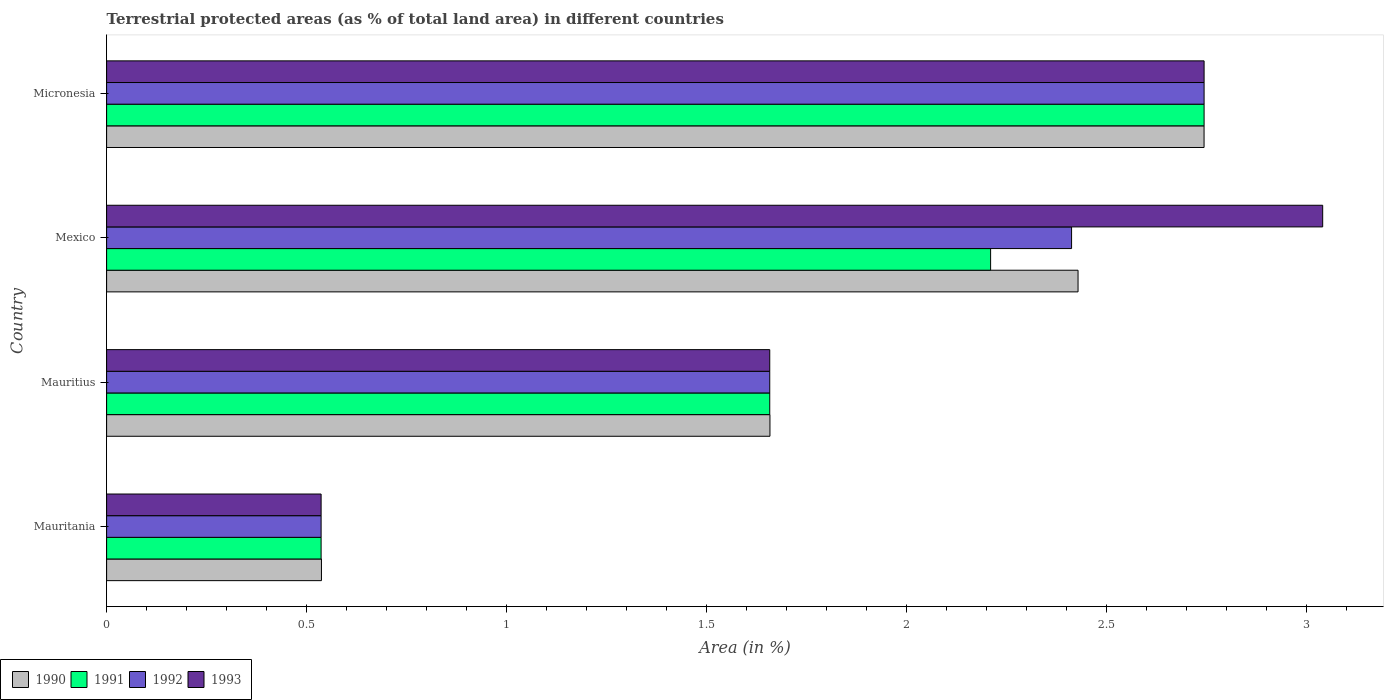How many groups of bars are there?
Provide a short and direct response. 4. Are the number of bars on each tick of the Y-axis equal?
Provide a short and direct response. Yes. How many bars are there on the 3rd tick from the top?
Your answer should be compact. 4. What is the label of the 4th group of bars from the top?
Your response must be concise. Mauritania. What is the percentage of terrestrial protected land in 1993 in Mauritius?
Your answer should be very brief. 1.66. Across all countries, what is the maximum percentage of terrestrial protected land in 1993?
Give a very brief answer. 3.04. Across all countries, what is the minimum percentage of terrestrial protected land in 1991?
Ensure brevity in your answer.  0.54. In which country was the percentage of terrestrial protected land in 1993 maximum?
Provide a succinct answer. Mexico. In which country was the percentage of terrestrial protected land in 1993 minimum?
Give a very brief answer. Mauritania. What is the total percentage of terrestrial protected land in 1991 in the graph?
Keep it short and to the point. 7.15. What is the difference between the percentage of terrestrial protected land in 1990 in Mexico and that in Micronesia?
Make the answer very short. -0.32. What is the difference between the percentage of terrestrial protected land in 1990 in Mauritania and the percentage of terrestrial protected land in 1991 in Mexico?
Make the answer very short. -1.67. What is the average percentage of terrestrial protected land in 1992 per country?
Give a very brief answer. 1.84. What is the ratio of the percentage of terrestrial protected land in 1992 in Mexico to that in Micronesia?
Your response must be concise. 0.88. Is the percentage of terrestrial protected land in 1991 in Mauritius less than that in Mexico?
Offer a very short reply. Yes. Is the difference between the percentage of terrestrial protected land in 1992 in Mexico and Micronesia greater than the difference between the percentage of terrestrial protected land in 1993 in Mexico and Micronesia?
Your response must be concise. No. What is the difference between the highest and the second highest percentage of terrestrial protected land in 1993?
Offer a terse response. 0.3. What is the difference between the highest and the lowest percentage of terrestrial protected land in 1993?
Give a very brief answer. 2.5. Is the sum of the percentage of terrestrial protected land in 1992 in Mauritania and Mauritius greater than the maximum percentage of terrestrial protected land in 1993 across all countries?
Give a very brief answer. No. Is it the case that in every country, the sum of the percentage of terrestrial protected land in 1993 and percentage of terrestrial protected land in 1990 is greater than the sum of percentage of terrestrial protected land in 1991 and percentage of terrestrial protected land in 1992?
Offer a terse response. No. What does the 4th bar from the top in Mauritius represents?
Keep it short and to the point. 1990. What does the 4th bar from the bottom in Mexico represents?
Your answer should be compact. 1993. Are all the bars in the graph horizontal?
Your answer should be very brief. Yes. What is the difference between two consecutive major ticks on the X-axis?
Offer a terse response. 0.5. Are the values on the major ticks of X-axis written in scientific E-notation?
Your answer should be very brief. No. Does the graph contain grids?
Keep it short and to the point. No. How many legend labels are there?
Your answer should be very brief. 4. What is the title of the graph?
Make the answer very short. Terrestrial protected areas (as % of total land area) in different countries. Does "1974" appear as one of the legend labels in the graph?
Your answer should be very brief. No. What is the label or title of the X-axis?
Your response must be concise. Area (in %). What is the Area (in %) in 1990 in Mauritania?
Offer a very short reply. 0.54. What is the Area (in %) of 1991 in Mauritania?
Offer a terse response. 0.54. What is the Area (in %) in 1992 in Mauritania?
Provide a succinct answer. 0.54. What is the Area (in %) in 1993 in Mauritania?
Give a very brief answer. 0.54. What is the Area (in %) in 1990 in Mauritius?
Make the answer very short. 1.66. What is the Area (in %) in 1991 in Mauritius?
Give a very brief answer. 1.66. What is the Area (in %) in 1992 in Mauritius?
Offer a terse response. 1.66. What is the Area (in %) of 1993 in Mauritius?
Keep it short and to the point. 1.66. What is the Area (in %) in 1990 in Mexico?
Give a very brief answer. 2.43. What is the Area (in %) in 1991 in Mexico?
Offer a terse response. 2.21. What is the Area (in %) of 1992 in Mexico?
Keep it short and to the point. 2.41. What is the Area (in %) in 1993 in Mexico?
Offer a very short reply. 3.04. What is the Area (in %) of 1990 in Micronesia?
Offer a very short reply. 2.74. What is the Area (in %) in 1991 in Micronesia?
Make the answer very short. 2.74. What is the Area (in %) of 1992 in Micronesia?
Ensure brevity in your answer.  2.74. What is the Area (in %) in 1993 in Micronesia?
Make the answer very short. 2.74. Across all countries, what is the maximum Area (in %) of 1990?
Offer a very short reply. 2.74. Across all countries, what is the maximum Area (in %) of 1991?
Offer a terse response. 2.74. Across all countries, what is the maximum Area (in %) of 1992?
Ensure brevity in your answer.  2.74. Across all countries, what is the maximum Area (in %) in 1993?
Your answer should be very brief. 3.04. Across all countries, what is the minimum Area (in %) of 1990?
Offer a very short reply. 0.54. Across all countries, what is the minimum Area (in %) in 1991?
Offer a very short reply. 0.54. Across all countries, what is the minimum Area (in %) of 1992?
Offer a terse response. 0.54. Across all countries, what is the minimum Area (in %) of 1993?
Offer a very short reply. 0.54. What is the total Area (in %) of 1990 in the graph?
Make the answer very short. 7.37. What is the total Area (in %) of 1991 in the graph?
Make the answer very short. 7.15. What is the total Area (in %) in 1992 in the graph?
Your answer should be very brief. 7.35. What is the total Area (in %) in 1993 in the graph?
Offer a very short reply. 7.98. What is the difference between the Area (in %) in 1990 in Mauritania and that in Mauritius?
Ensure brevity in your answer.  -1.12. What is the difference between the Area (in %) in 1991 in Mauritania and that in Mauritius?
Your response must be concise. -1.12. What is the difference between the Area (in %) of 1992 in Mauritania and that in Mauritius?
Your answer should be very brief. -1.12. What is the difference between the Area (in %) of 1993 in Mauritania and that in Mauritius?
Ensure brevity in your answer.  -1.12. What is the difference between the Area (in %) in 1990 in Mauritania and that in Mexico?
Offer a terse response. -1.89. What is the difference between the Area (in %) of 1991 in Mauritania and that in Mexico?
Ensure brevity in your answer.  -1.67. What is the difference between the Area (in %) in 1992 in Mauritania and that in Mexico?
Provide a succinct answer. -1.88. What is the difference between the Area (in %) in 1993 in Mauritania and that in Mexico?
Keep it short and to the point. -2.5. What is the difference between the Area (in %) in 1990 in Mauritania and that in Micronesia?
Your answer should be very brief. -2.21. What is the difference between the Area (in %) of 1991 in Mauritania and that in Micronesia?
Keep it short and to the point. -2.21. What is the difference between the Area (in %) in 1992 in Mauritania and that in Micronesia?
Your response must be concise. -2.21. What is the difference between the Area (in %) of 1993 in Mauritania and that in Micronesia?
Your response must be concise. -2.21. What is the difference between the Area (in %) of 1990 in Mauritius and that in Mexico?
Your answer should be compact. -0.77. What is the difference between the Area (in %) of 1991 in Mauritius and that in Mexico?
Your answer should be very brief. -0.55. What is the difference between the Area (in %) of 1992 in Mauritius and that in Mexico?
Offer a terse response. -0.75. What is the difference between the Area (in %) in 1993 in Mauritius and that in Mexico?
Keep it short and to the point. -1.38. What is the difference between the Area (in %) in 1990 in Mauritius and that in Micronesia?
Your answer should be compact. -1.09. What is the difference between the Area (in %) in 1991 in Mauritius and that in Micronesia?
Provide a succinct answer. -1.09. What is the difference between the Area (in %) in 1992 in Mauritius and that in Micronesia?
Offer a terse response. -1.09. What is the difference between the Area (in %) of 1993 in Mauritius and that in Micronesia?
Your answer should be compact. -1.09. What is the difference between the Area (in %) in 1990 in Mexico and that in Micronesia?
Keep it short and to the point. -0.32. What is the difference between the Area (in %) of 1991 in Mexico and that in Micronesia?
Your answer should be very brief. -0.53. What is the difference between the Area (in %) in 1992 in Mexico and that in Micronesia?
Keep it short and to the point. -0.33. What is the difference between the Area (in %) of 1993 in Mexico and that in Micronesia?
Your answer should be very brief. 0.3. What is the difference between the Area (in %) in 1990 in Mauritania and the Area (in %) in 1991 in Mauritius?
Offer a very short reply. -1.12. What is the difference between the Area (in %) of 1990 in Mauritania and the Area (in %) of 1992 in Mauritius?
Your answer should be very brief. -1.12. What is the difference between the Area (in %) in 1990 in Mauritania and the Area (in %) in 1993 in Mauritius?
Provide a succinct answer. -1.12. What is the difference between the Area (in %) in 1991 in Mauritania and the Area (in %) in 1992 in Mauritius?
Provide a short and direct response. -1.12. What is the difference between the Area (in %) of 1991 in Mauritania and the Area (in %) of 1993 in Mauritius?
Offer a terse response. -1.12. What is the difference between the Area (in %) in 1992 in Mauritania and the Area (in %) in 1993 in Mauritius?
Your response must be concise. -1.12. What is the difference between the Area (in %) of 1990 in Mauritania and the Area (in %) of 1991 in Mexico?
Your answer should be very brief. -1.67. What is the difference between the Area (in %) of 1990 in Mauritania and the Area (in %) of 1992 in Mexico?
Your answer should be compact. -1.88. What is the difference between the Area (in %) of 1990 in Mauritania and the Area (in %) of 1993 in Mexico?
Your answer should be compact. -2.5. What is the difference between the Area (in %) in 1991 in Mauritania and the Area (in %) in 1992 in Mexico?
Your response must be concise. -1.88. What is the difference between the Area (in %) of 1991 in Mauritania and the Area (in %) of 1993 in Mexico?
Offer a very short reply. -2.5. What is the difference between the Area (in %) of 1992 in Mauritania and the Area (in %) of 1993 in Mexico?
Provide a short and direct response. -2.5. What is the difference between the Area (in %) in 1990 in Mauritania and the Area (in %) in 1991 in Micronesia?
Your response must be concise. -2.21. What is the difference between the Area (in %) in 1990 in Mauritania and the Area (in %) in 1992 in Micronesia?
Provide a succinct answer. -2.21. What is the difference between the Area (in %) in 1990 in Mauritania and the Area (in %) in 1993 in Micronesia?
Provide a succinct answer. -2.21. What is the difference between the Area (in %) of 1991 in Mauritania and the Area (in %) of 1992 in Micronesia?
Ensure brevity in your answer.  -2.21. What is the difference between the Area (in %) of 1991 in Mauritania and the Area (in %) of 1993 in Micronesia?
Give a very brief answer. -2.21. What is the difference between the Area (in %) in 1992 in Mauritania and the Area (in %) in 1993 in Micronesia?
Keep it short and to the point. -2.21. What is the difference between the Area (in %) in 1990 in Mauritius and the Area (in %) in 1991 in Mexico?
Keep it short and to the point. -0.55. What is the difference between the Area (in %) of 1990 in Mauritius and the Area (in %) of 1992 in Mexico?
Provide a succinct answer. -0.75. What is the difference between the Area (in %) of 1990 in Mauritius and the Area (in %) of 1993 in Mexico?
Provide a short and direct response. -1.38. What is the difference between the Area (in %) in 1991 in Mauritius and the Area (in %) in 1992 in Mexico?
Give a very brief answer. -0.75. What is the difference between the Area (in %) of 1991 in Mauritius and the Area (in %) of 1993 in Mexico?
Offer a terse response. -1.38. What is the difference between the Area (in %) of 1992 in Mauritius and the Area (in %) of 1993 in Mexico?
Give a very brief answer. -1.38. What is the difference between the Area (in %) in 1990 in Mauritius and the Area (in %) in 1991 in Micronesia?
Make the answer very short. -1.09. What is the difference between the Area (in %) in 1990 in Mauritius and the Area (in %) in 1992 in Micronesia?
Offer a terse response. -1.09. What is the difference between the Area (in %) in 1990 in Mauritius and the Area (in %) in 1993 in Micronesia?
Your response must be concise. -1.09. What is the difference between the Area (in %) in 1991 in Mauritius and the Area (in %) in 1992 in Micronesia?
Keep it short and to the point. -1.09. What is the difference between the Area (in %) in 1991 in Mauritius and the Area (in %) in 1993 in Micronesia?
Provide a short and direct response. -1.09. What is the difference between the Area (in %) in 1992 in Mauritius and the Area (in %) in 1993 in Micronesia?
Your answer should be very brief. -1.09. What is the difference between the Area (in %) in 1990 in Mexico and the Area (in %) in 1991 in Micronesia?
Your response must be concise. -0.32. What is the difference between the Area (in %) of 1990 in Mexico and the Area (in %) of 1992 in Micronesia?
Your response must be concise. -0.32. What is the difference between the Area (in %) of 1990 in Mexico and the Area (in %) of 1993 in Micronesia?
Your answer should be compact. -0.32. What is the difference between the Area (in %) of 1991 in Mexico and the Area (in %) of 1992 in Micronesia?
Offer a very short reply. -0.53. What is the difference between the Area (in %) of 1991 in Mexico and the Area (in %) of 1993 in Micronesia?
Ensure brevity in your answer.  -0.53. What is the difference between the Area (in %) of 1992 in Mexico and the Area (in %) of 1993 in Micronesia?
Provide a succinct answer. -0.33. What is the average Area (in %) in 1990 per country?
Offer a very short reply. 1.84. What is the average Area (in %) of 1991 per country?
Provide a short and direct response. 1.79. What is the average Area (in %) in 1992 per country?
Make the answer very short. 1.84. What is the average Area (in %) of 1993 per country?
Your response must be concise. 1.99. What is the difference between the Area (in %) in 1990 and Area (in %) in 1991 in Mauritania?
Your answer should be compact. 0. What is the difference between the Area (in %) of 1990 and Area (in %) of 1992 in Mauritania?
Keep it short and to the point. 0. What is the difference between the Area (in %) in 1990 and Area (in %) in 1993 in Mauritania?
Make the answer very short. 0. What is the difference between the Area (in %) in 1991 and Area (in %) in 1992 in Mauritania?
Keep it short and to the point. 0. What is the difference between the Area (in %) in 1991 and Area (in %) in 1993 in Mauritania?
Your response must be concise. 0. What is the difference between the Area (in %) of 1990 and Area (in %) of 1991 in Mauritius?
Give a very brief answer. 0. What is the difference between the Area (in %) in 1990 and Area (in %) in 1992 in Mauritius?
Provide a short and direct response. 0. What is the difference between the Area (in %) in 1991 and Area (in %) in 1992 in Mauritius?
Your answer should be very brief. 0. What is the difference between the Area (in %) of 1990 and Area (in %) of 1991 in Mexico?
Ensure brevity in your answer.  0.22. What is the difference between the Area (in %) in 1990 and Area (in %) in 1992 in Mexico?
Provide a short and direct response. 0.02. What is the difference between the Area (in %) of 1990 and Area (in %) of 1993 in Mexico?
Your answer should be compact. -0.61. What is the difference between the Area (in %) in 1991 and Area (in %) in 1992 in Mexico?
Keep it short and to the point. -0.2. What is the difference between the Area (in %) in 1991 and Area (in %) in 1993 in Mexico?
Offer a terse response. -0.83. What is the difference between the Area (in %) in 1992 and Area (in %) in 1993 in Mexico?
Your answer should be compact. -0.63. What is the difference between the Area (in %) of 1990 and Area (in %) of 1991 in Micronesia?
Your response must be concise. -0. What is the difference between the Area (in %) in 1990 and Area (in %) in 1992 in Micronesia?
Give a very brief answer. -0. What is the difference between the Area (in %) of 1990 and Area (in %) of 1993 in Micronesia?
Your answer should be compact. -0. What is the ratio of the Area (in %) in 1990 in Mauritania to that in Mauritius?
Give a very brief answer. 0.32. What is the ratio of the Area (in %) in 1991 in Mauritania to that in Mauritius?
Offer a very short reply. 0.32. What is the ratio of the Area (in %) in 1992 in Mauritania to that in Mauritius?
Your answer should be compact. 0.32. What is the ratio of the Area (in %) in 1993 in Mauritania to that in Mauritius?
Offer a very short reply. 0.32. What is the ratio of the Area (in %) in 1990 in Mauritania to that in Mexico?
Give a very brief answer. 0.22. What is the ratio of the Area (in %) in 1991 in Mauritania to that in Mexico?
Provide a succinct answer. 0.24. What is the ratio of the Area (in %) of 1992 in Mauritania to that in Mexico?
Provide a short and direct response. 0.22. What is the ratio of the Area (in %) of 1993 in Mauritania to that in Mexico?
Your answer should be compact. 0.18. What is the ratio of the Area (in %) in 1990 in Mauritania to that in Micronesia?
Give a very brief answer. 0.2. What is the ratio of the Area (in %) of 1991 in Mauritania to that in Micronesia?
Provide a succinct answer. 0.2. What is the ratio of the Area (in %) of 1992 in Mauritania to that in Micronesia?
Keep it short and to the point. 0.2. What is the ratio of the Area (in %) of 1993 in Mauritania to that in Micronesia?
Give a very brief answer. 0.2. What is the ratio of the Area (in %) of 1990 in Mauritius to that in Mexico?
Offer a terse response. 0.68. What is the ratio of the Area (in %) in 1991 in Mauritius to that in Mexico?
Keep it short and to the point. 0.75. What is the ratio of the Area (in %) of 1992 in Mauritius to that in Mexico?
Offer a very short reply. 0.69. What is the ratio of the Area (in %) in 1993 in Mauritius to that in Mexico?
Provide a short and direct response. 0.55. What is the ratio of the Area (in %) in 1990 in Mauritius to that in Micronesia?
Ensure brevity in your answer.  0.6. What is the ratio of the Area (in %) in 1991 in Mauritius to that in Micronesia?
Provide a short and direct response. 0.6. What is the ratio of the Area (in %) of 1992 in Mauritius to that in Micronesia?
Make the answer very short. 0.6. What is the ratio of the Area (in %) of 1993 in Mauritius to that in Micronesia?
Your answer should be compact. 0.6. What is the ratio of the Area (in %) in 1990 in Mexico to that in Micronesia?
Keep it short and to the point. 0.89. What is the ratio of the Area (in %) of 1991 in Mexico to that in Micronesia?
Ensure brevity in your answer.  0.81. What is the ratio of the Area (in %) in 1992 in Mexico to that in Micronesia?
Give a very brief answer. 0.88. What is the ratio of the Area (in %) in 1993 in Mexico to that in Micronesia?
Make the answer very short. 1.11. What is the difference between the highest and the second highest Area (in %) in 1990?
Your response must be concise. 0.32. What is the difference between the highest and the second highest Area (in %) in 1991?
Make the answer very short. 0.53. What is the difference between the highest and the second highest Area (in %) in 1992?
Your answer should be compact. 0.33. What is the difference between the highest and the second highest Area (in %) in 1993?
Provide a short and direct response. 0.3. What is the difference between the highest and the lowest Area (in %) of 1990?
Ensure brevity in your answer.  2.21. What is the difference between the highest and the lowest Area (in %) in 1991?
Ensure brevity in your answer.  2.21. What is the difference between the highest and the lowest Area (in %) in 1992?
Your response must be concise. 2.21. What is the difference between the highest and the lowest Area (in %) in 1993?
Keep it short and to the point. 2.5. 